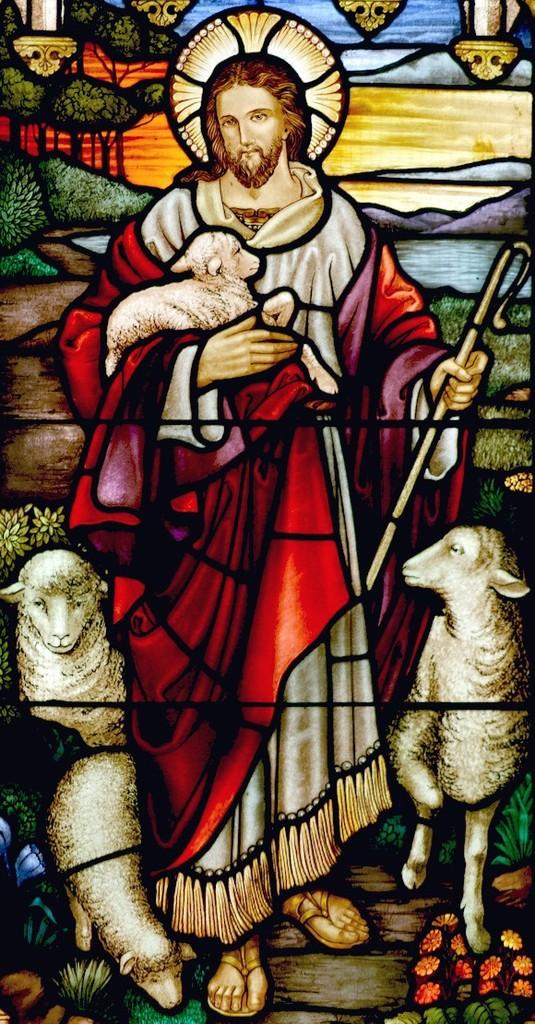What type of animals are depicted in the image? There is a depiction of sheep in the image. Are there any human figures in the image? Yes, there is a depiction of a man in the image. What other elements can be seen in the image besides the sheep and the man? There are depictions of other things in the image. What type of mint is being offered by the man in the image? There is no mint or any indication of an offer in the image. 